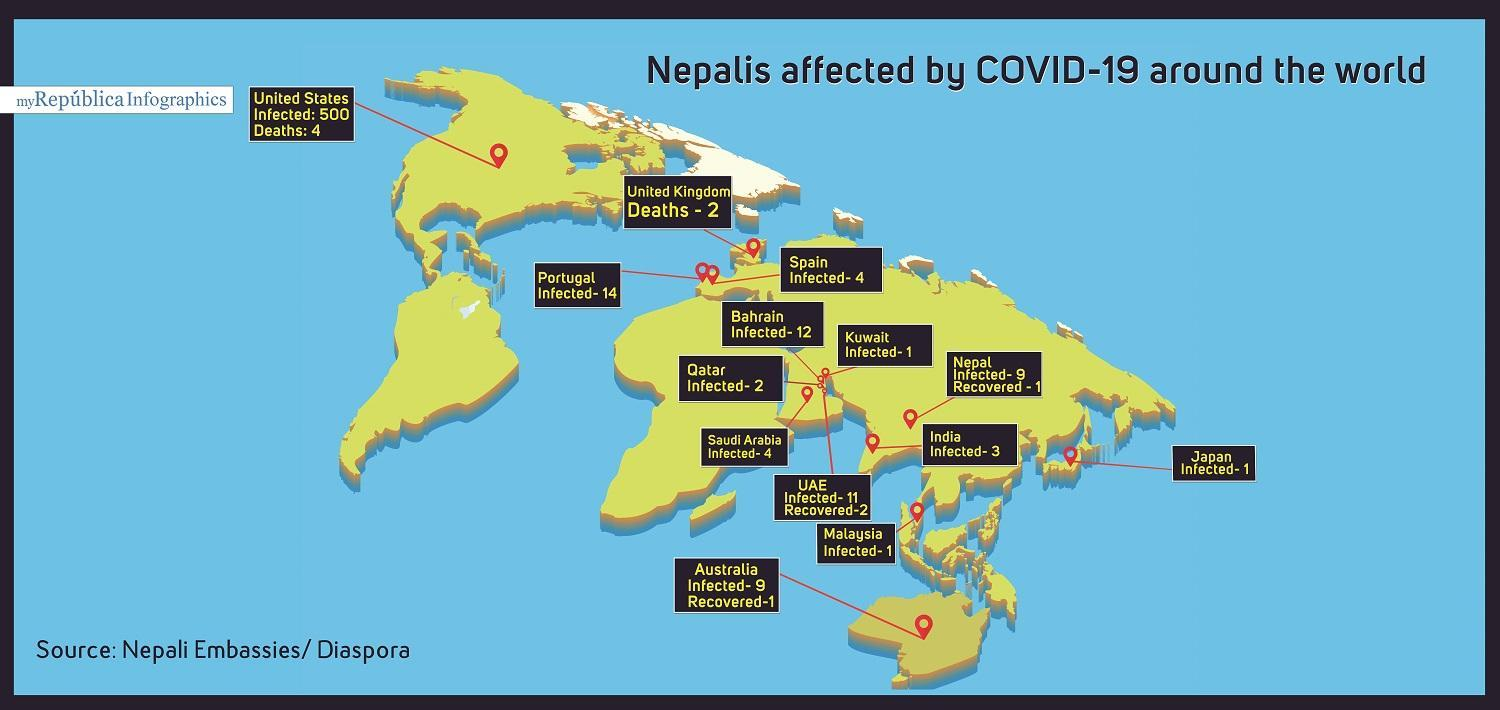Where have deaths of Nepalis been reported
Answer the question with a short phrase. united kingdom, united states IN total, how many deaths of Nepalis have been reported 6 where have recoveries of Nepalis been reported Nepal, Australia, UAE In which countries have only 1 Nepali been infested Japan, Malaysia, Kuwait 